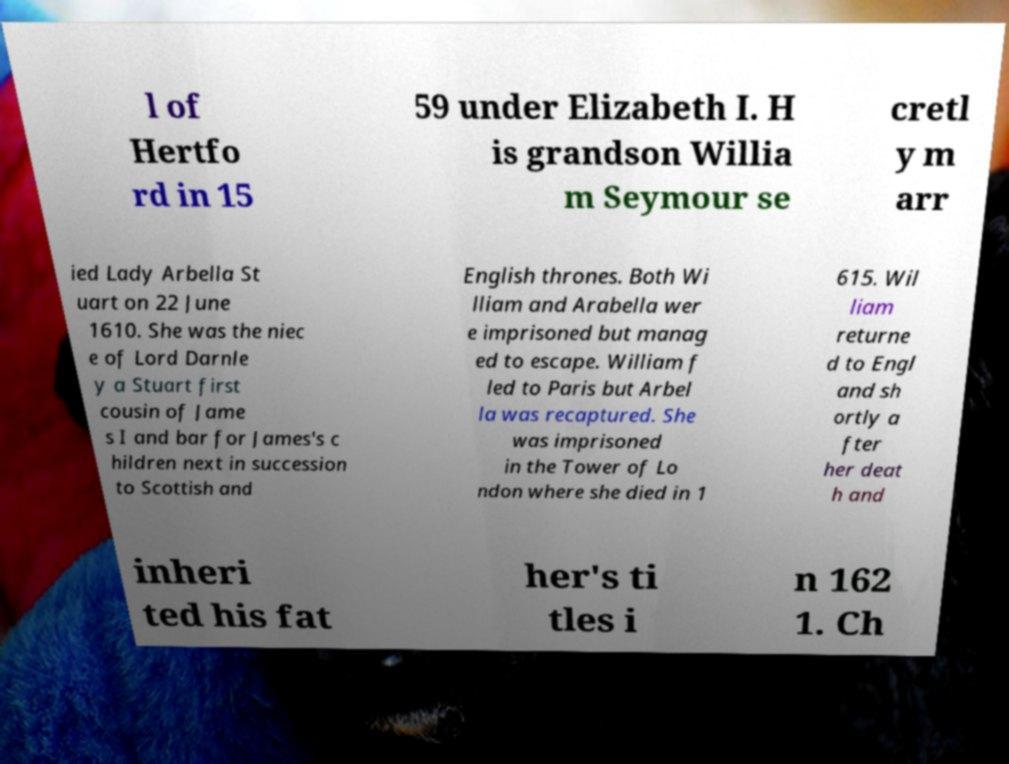For documentation purposes, I need the text within this image transcribed. Could you provide that? l of Hertfo rd in 15 59 under Elizabeth I. H is grandson Willia m Seymour se cretl y m arr ied Lady Arbella St uart on 22 June 1610. She was the niec e of Lord Darnle y a Stuart first cousin of Jame s I and bar for James's c hildren next in succession to Scottish and English thrones. Both Wi lliam and Arabella wer e imprisoned but manag ed to escape. William f led to Paris but Arbel la was recaptured. She was imprisoned in the Tower of Lo ndon where she died in 1 615. Wil liam returne d to Engl and sh ortly a fter her deat h and inheri ted his fat her's ti tles i n 162 1. Ch 